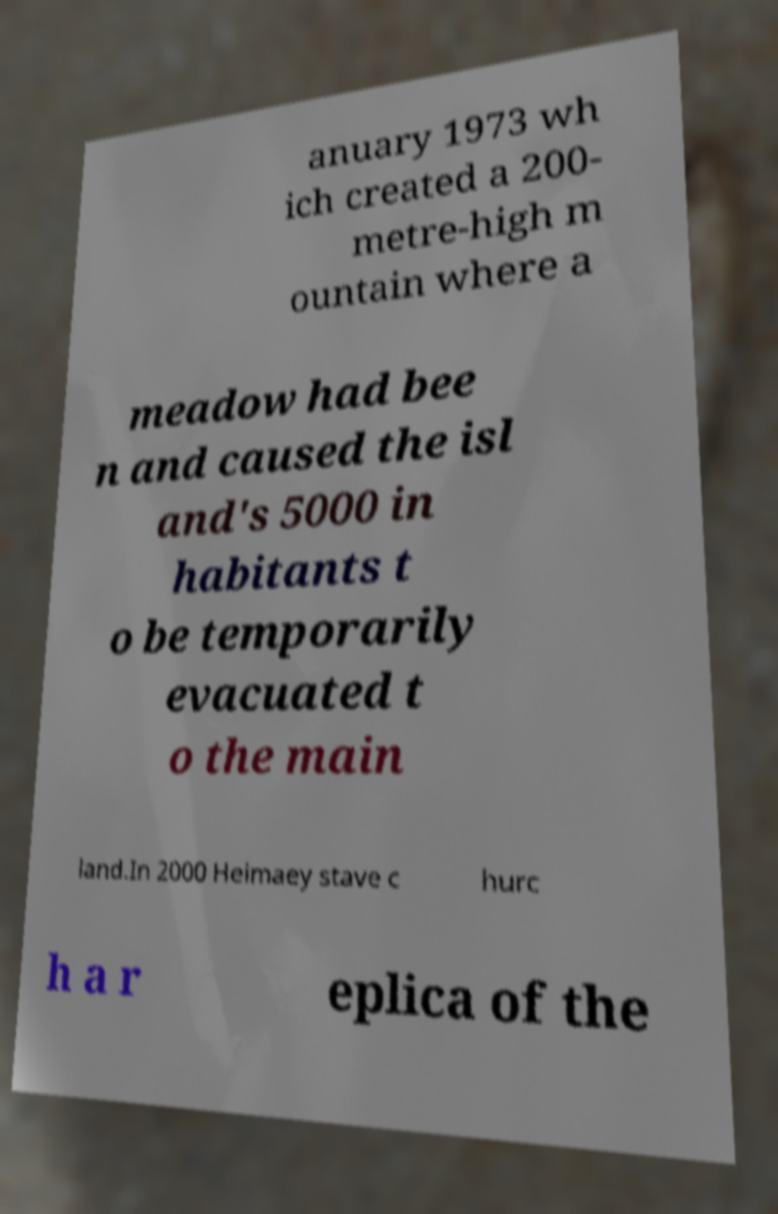Can you read and provide the text displayed in the image?This photo seems to have some interesting text. Can you extract and type it out for me? anuary 1973 wh ich created a 200- metre-high m ountain where a meadow had bee n and caused the isl and's 5000 in habitants t o be temporarily evacuated t o the main land.In 2000 Heimaey stave c hurc h a r eplica of the 